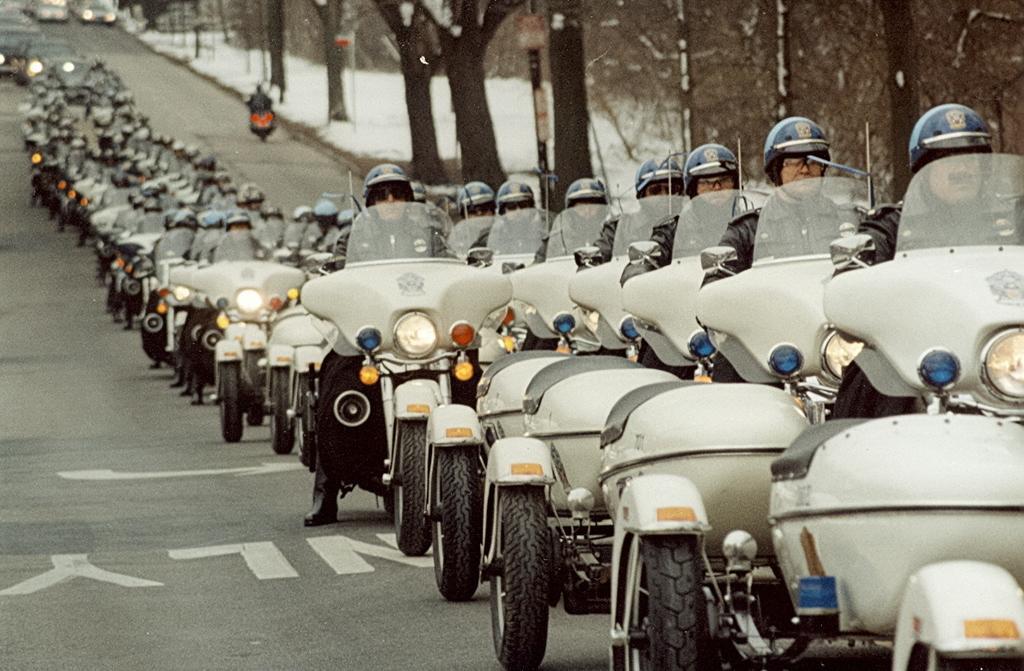Please provide a concise description of this image. In this picture there are group of bikes standing on the road. All the bikes are in grey in color with blue lights and yellow radius sticker. All the men on the bikes are wearing black jackets and blue helmets. In the background there are group of trees. 